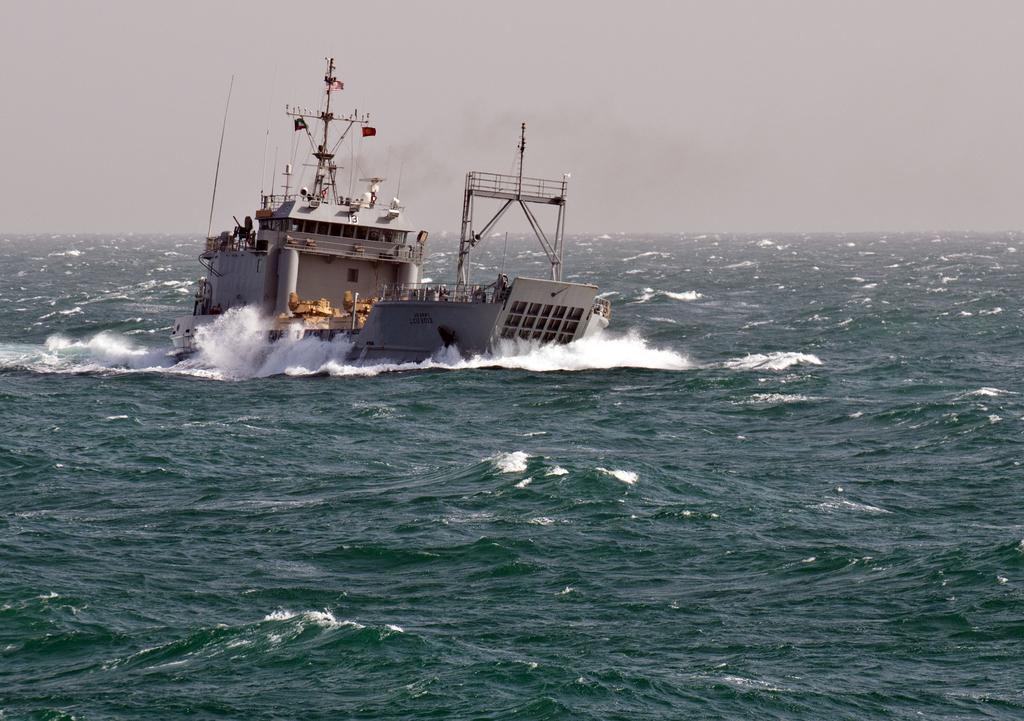What is the main subject in the picture? The main subject in the picture is a ship. Where is the ship located in the picture? The ship is in the center of the picture. What is the background of the picture? There is a water body in the picture, and the sky is cloudy. What type of muscle can be seen flexing on the ship's deck in the image? There is no muscle visible on the ship's deck in the image. How much profit is the ship generating in the image? The image does not provide information about the ship's profit, as it is a still image and not a real-time representation of the ship's activities. 